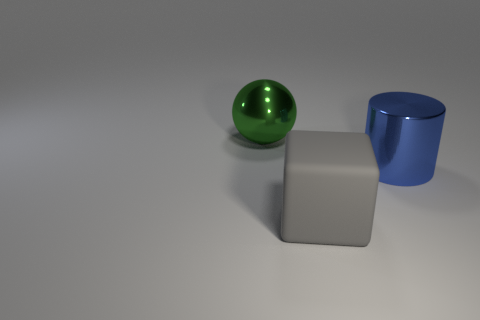How many matte objects are behind the big shiny thing that is to the right of the metallic object that is left of the blue metal cylinder?
Provide a short and direct response. 0. Is the number of blue cylinders that are on the left side of the blue shiny cylinder less than the number of brown cubes?
Your response must be concise. No. Is there any other thing that has the same shape as the big green shiny object?
Offer a very short reply. No. What shape is the large thing behind the big blue metallic thing?
Ensure brevity in your answer.  Sphere. There is a large metallic thing that is left of the metallic object in front of the metal object left of the matte thing; what is its shape?
Keep it short and to the point. Sphere. How many objects are green metallic spheres or large purple rubber balls?
Offer a terse response. 1. There is a metallic object that is behind the big blue cylinder; is it the same shape as the big metal thing that is in front of the large green ball?
Your answer should be very brief. No. What number of things are behind the large blue cylinder and to the right of the green metallic object?
Keep it short and to the point. 0. What number of other things are the same size as the green metal object?
Offer a terse response. 2. What is the material of the object that is behind the large cube and to the left of the big blue object?
Your answer should be compact. Metal. 